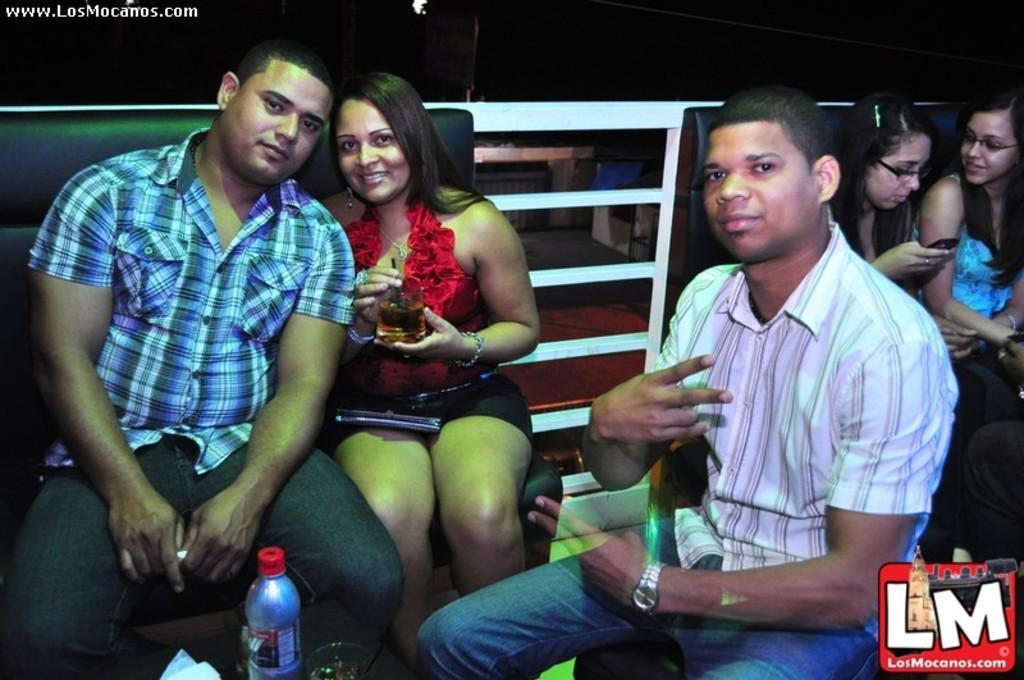Describe this image in one or two sentences. In this picture I can see there are three people sitting here and they are drinking wine, there are wine glasses in their hands and in the backdrop there is wall. 